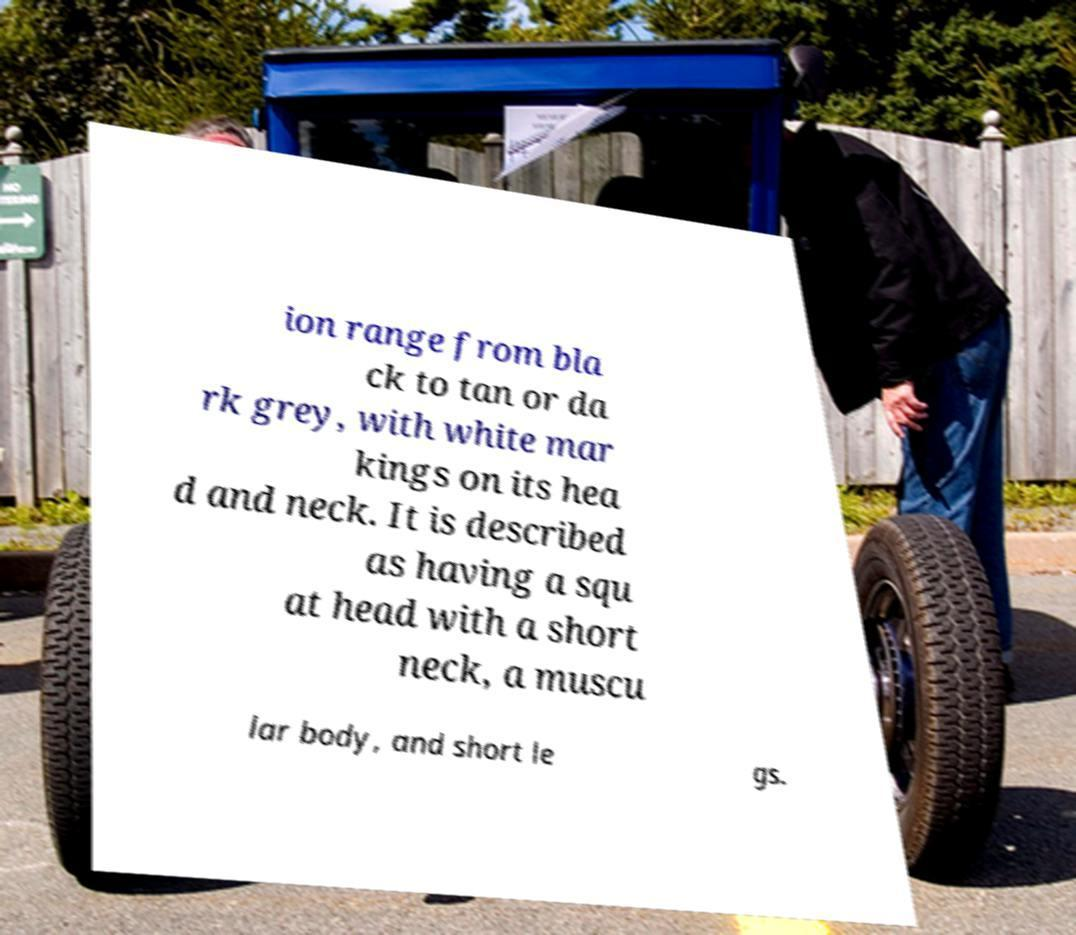Could you assist in decoding the text presented in this image and type it out clearly? ion range from bla ck to tan or da rk grey, with white mar kings on its hea d and neck. It is described as having a squ at head with a short neck, a muscu lar body, and short le gs. 